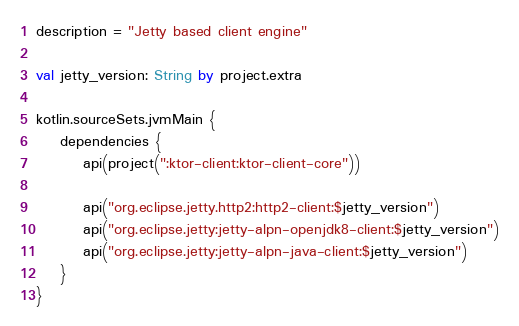Convert code to text. <code><loc_0><loc_0><loc_500><loc_500><_Kotlin_>description = "Jetty based client engine"

val jetty_version: String by project.extra

kotlin.sourceSets.jvmMain {
    dependencies {
        api(project(":ktor-client:ktor-client-core"))

        api("org.eclipse.jetty.http2:http2-client:$jetty_version")
        api("org.eclipse.jetty:jetty-alpn-openjdk8-client:$jetty_version")
        api("org.eclipse.jetty:jetty-alpn-java-client:$jetty_version")
    }
}
</code> 